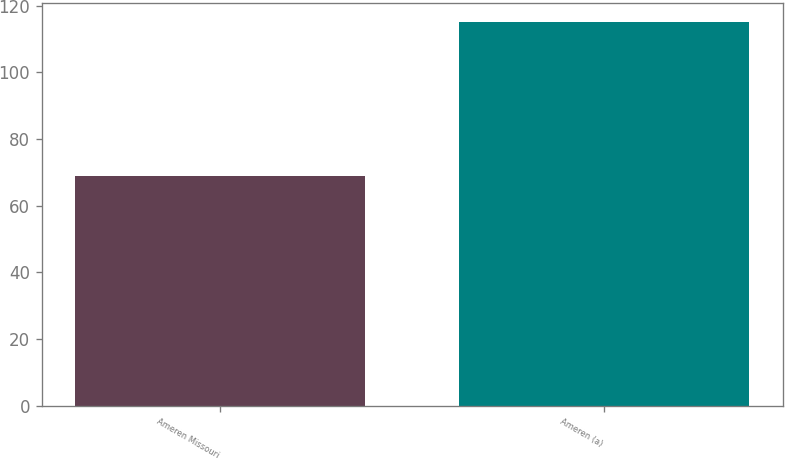Convert chart to OTSL. <chart><loc_0><loc_0><loc_500><loc_500><bar_chart><fcel>Ameren Missouri<fcel>Ameren (a)<nl><fcel>69<fcel>115<nl></chart> 